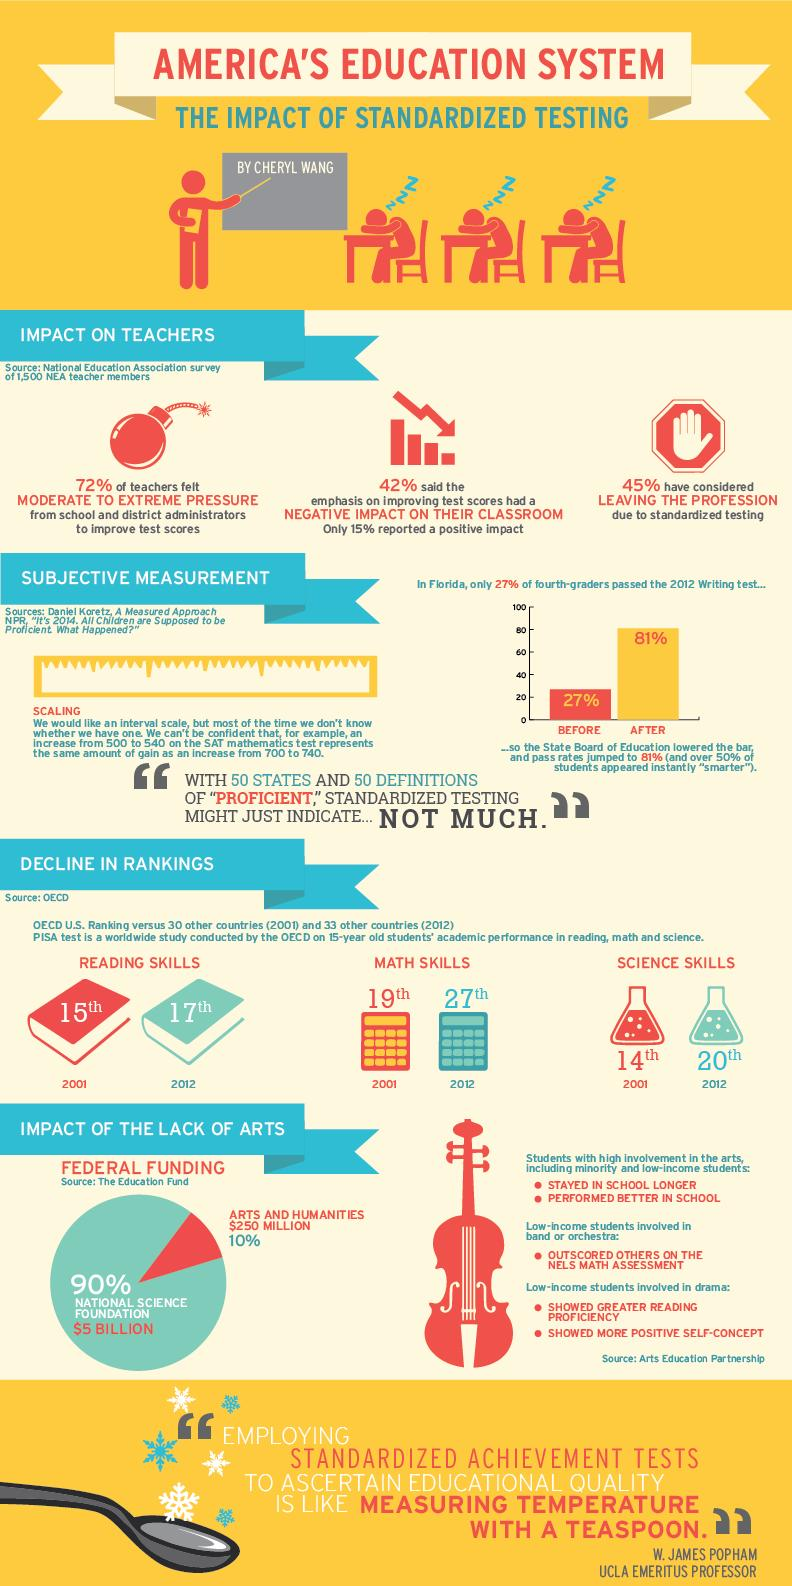Point out several critical features in this image. In 2001, the OECD reported that the United States ranked 19th out of 30 countries in math skills among participating nations. The OECD ranked the U.S. 20th out of 34 countries in science skills in 2012. The federal funding for Arts & Humanities is $250 MILLLION. The National Science Foundation has received approximately $5 billion in federal funding. 